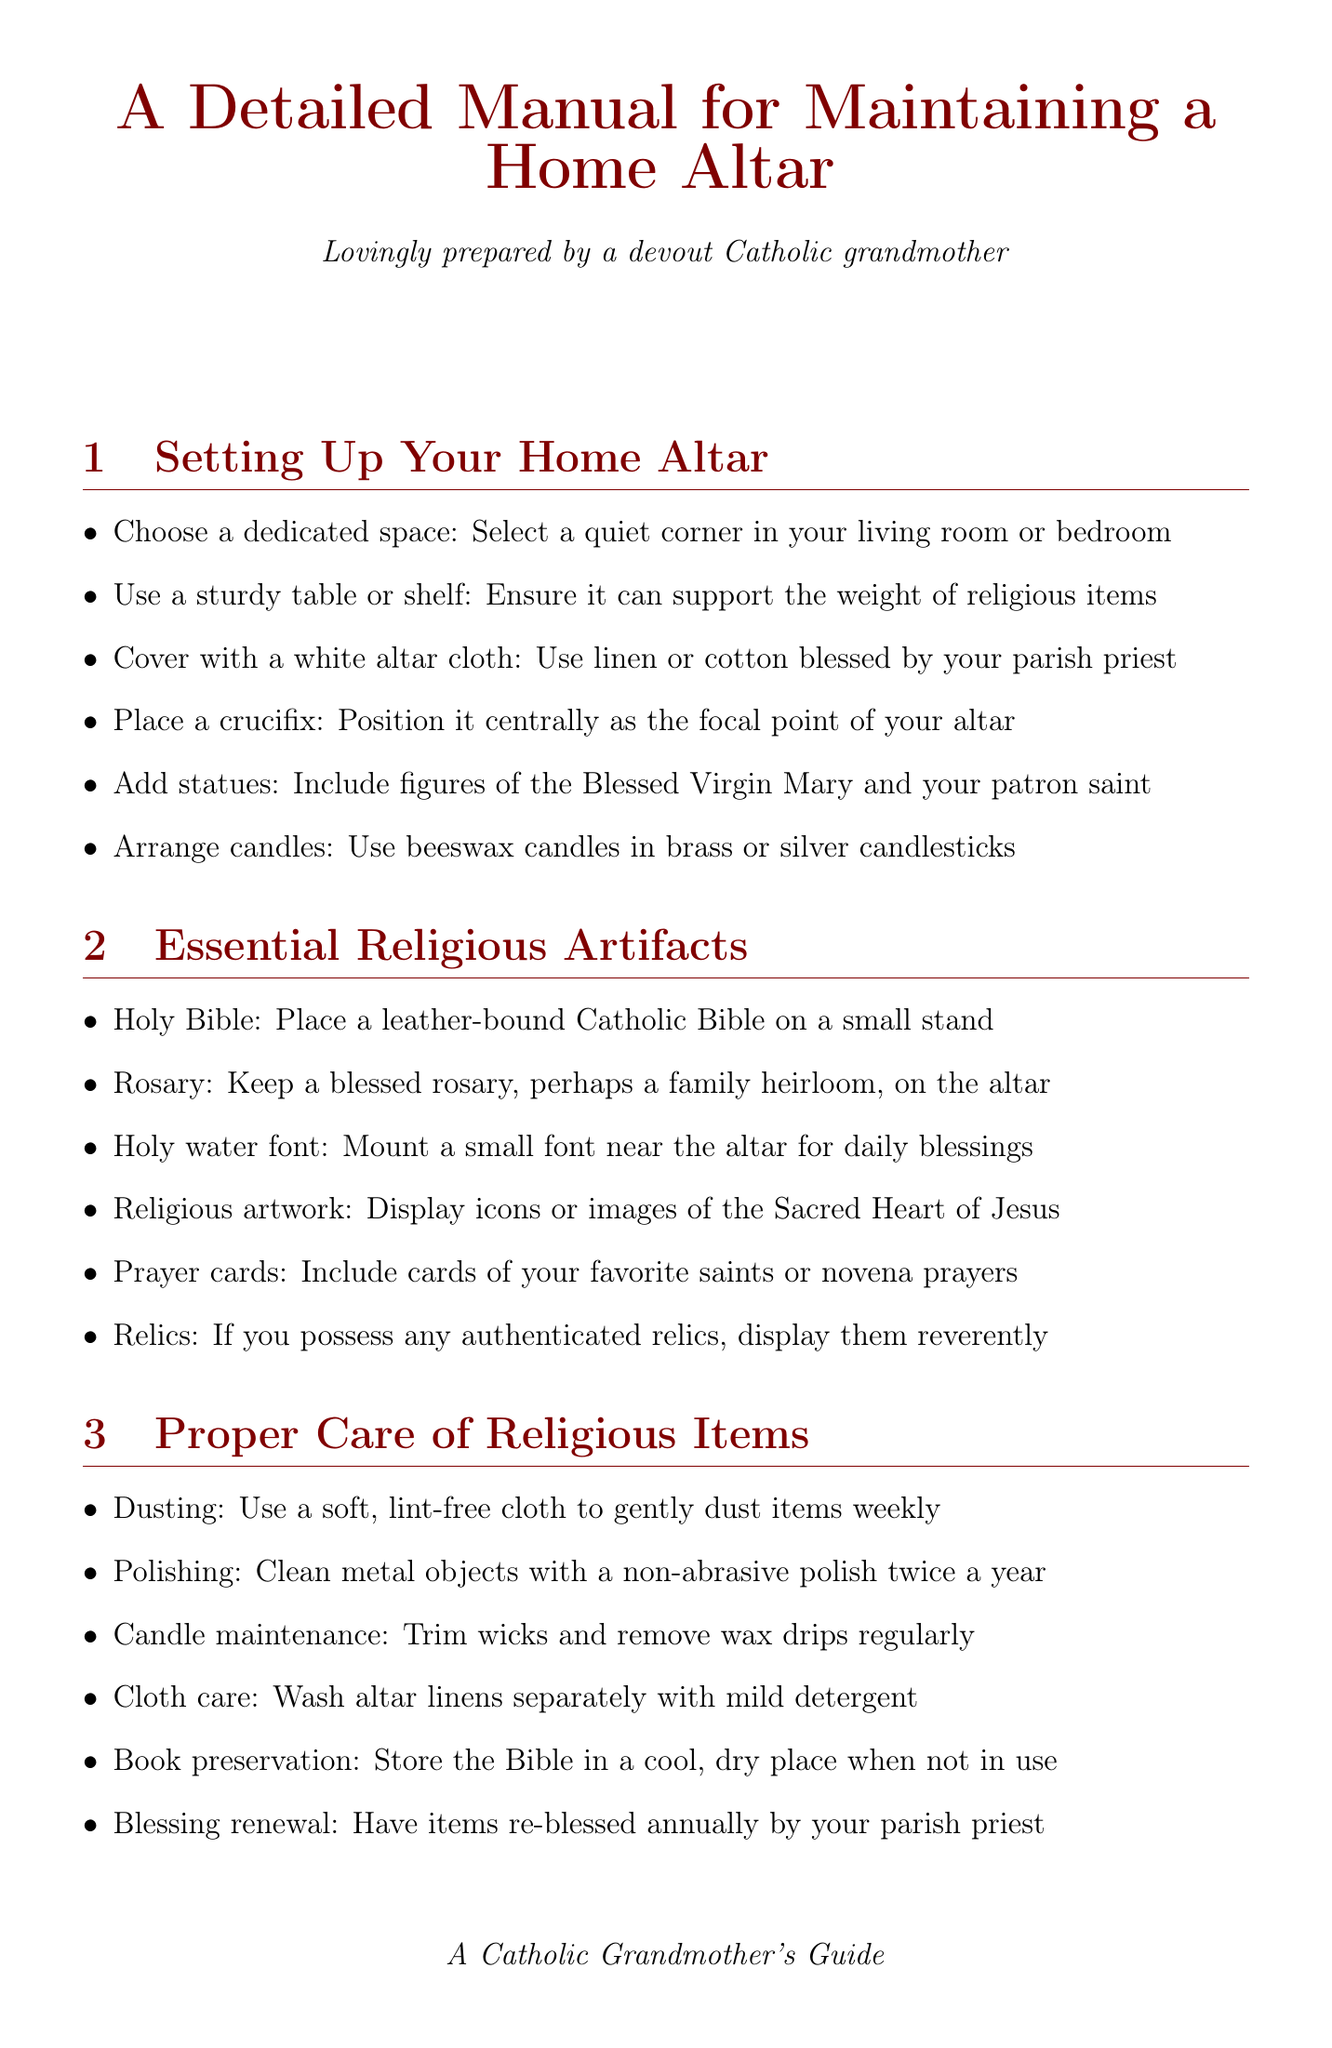what should you cover the altar with? The altar should be covered with a white altar cloth made from linen or cotton blessed by your parish priest.
Answer: white altar cloth how often should metal objects be polished? The document states that metal objects should be cleaned with a non-abrasive polish twice a year.
Answer: twice a year what color cloth is used during Advent? The document indicates that a purple cloth is to be used during Advent.
Answer: purple cloth what is a suggested daily prayer for seminarians? The document mentions starting the day with a morning offering as a prayer for seminarians.
Answer: morning offering who is the patron of parish priests mentioned in the document? St. John Vianney is identified as the patron of parish priests in the document.
Answer: St. John Vianney what type of candles should be arranged on the altar? The document specifies using beeswax candles in brass or silver candlesticks.
Answer: beeswax candles how often should the items on the altar be re-blessed? The document recommends having altar items re-blessed annually by your parish priest.
Answer: annually what seasonal decoration is added during Easter? The document states to decorate with white lilies and display a paschal candle during Easter.
Answer: white lilies and paschal candle what activity involves grandchildren according to the manual? The document encourages teaching grandchildren how to properly handle sacred objects.
Answer: teach grandchildren 